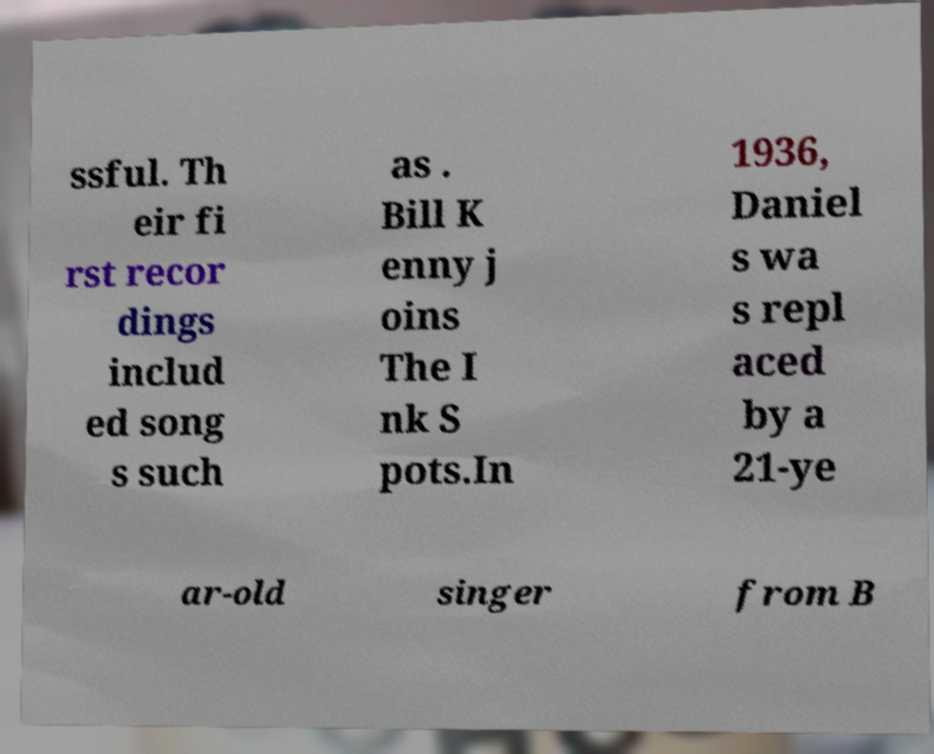I need the written content from this picture converted into text. Can you do that? ssful. Th eir fi rst recor dings includ ed song s such as . Bill K enny j oins The I nk S pots.In 1936, Daniel s wa s repl aced by a 21-ye ar-old singer from B 